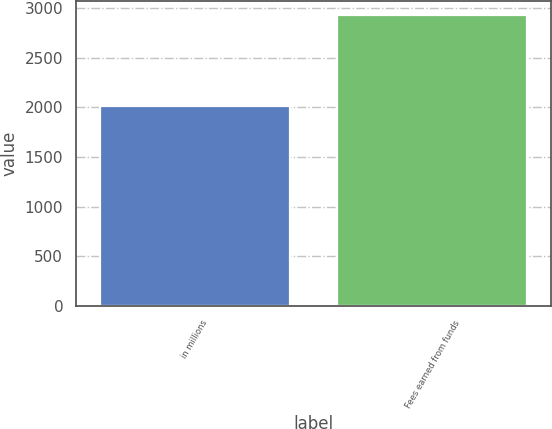<chart> <loc_0><loc_0><loc_500><loc_500><bar_chart><fcel>in millions<fcel>Fees earned from funds<nl><fcel>2017<fcel>2932<nl></chart> 